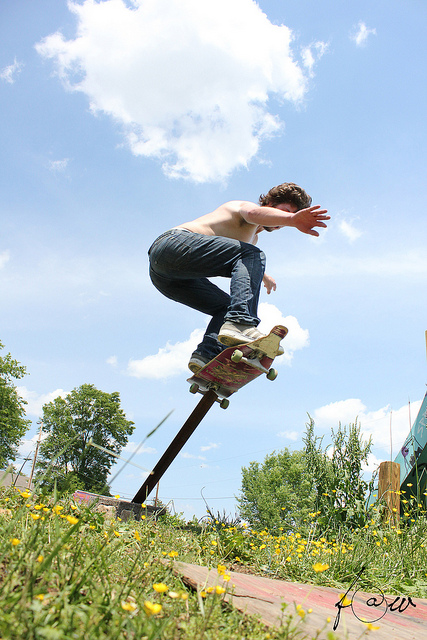Please transcribe the text information in this image. faw 